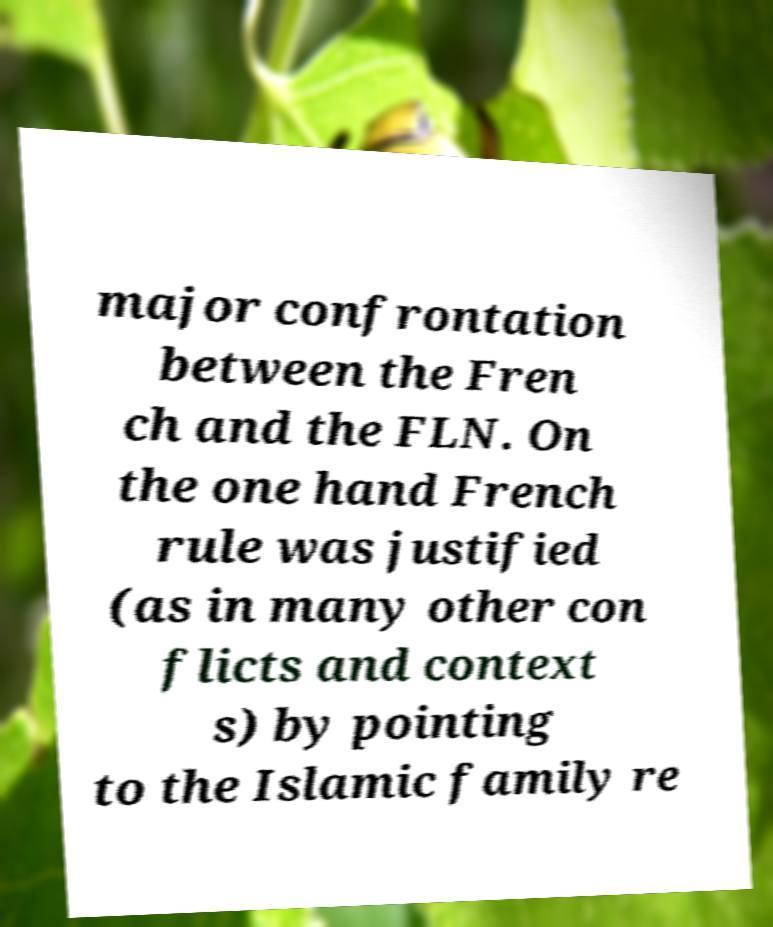Could you extract and type out the text from this image? major confrontation between the Fren ch and the FLN. On the one hand French rule was justified (as in many other con flicts and context s) by pointing to the Islamic family re 